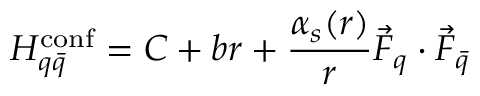Convert formula to latex. <formula><loc_0><loc_0><loc_500><loc_500>H _ { q \bar { q } } ^ { c o n f } = C + b r + { \frac { \alpha _ { s } ( r ) } { r } } \vec { F } _ { q } \cdot \vec { F } _ { \bar { q } }</formula> 